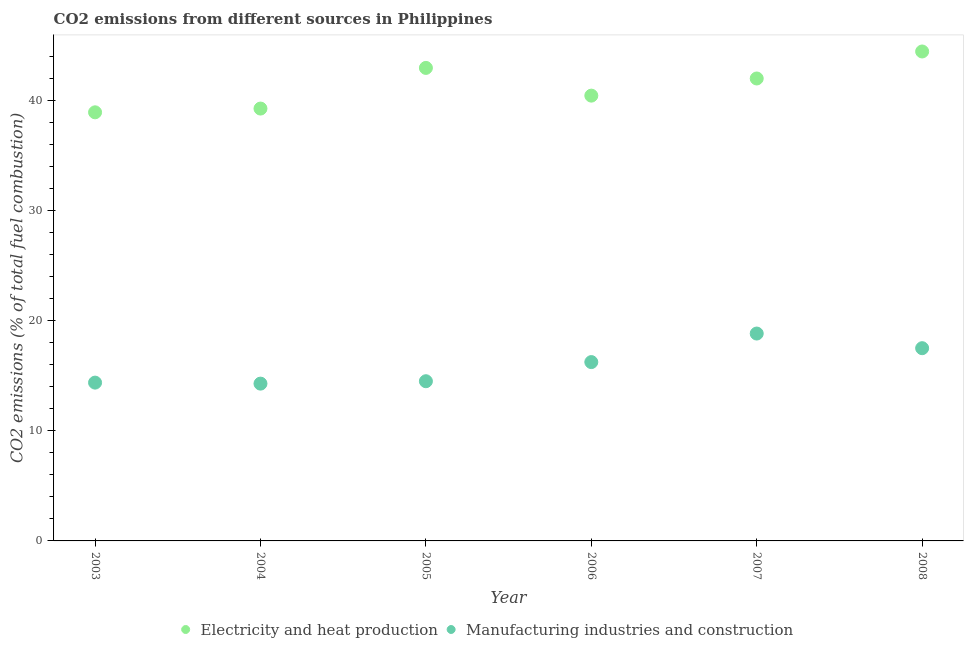How many different coloured dotlines are there?
Provide a short and direct response. 2. What is the co2 emissions due to manufacturing industries in 2003?
Provide a succinct answer. 14.38. Across all years, what is the maximum co2 emissions due to manufacturing industries?
Your response must be concise. 18.84. Across all years, what is the minimum co2 emissions due to manufacturing industries?
Provide a short and direct response. 14.29. In which year was the co2 emissions due to manufacturing industries minimum?
Your answer should be very brief. 2004. What is the total co2 emissions due to manufacturing industries in the graph?
Make the answer very short. 95.76. What is the difference between the co2 emissions due to electricity and heat production in 2006 and that in 2007?
Give a very brief answer. -1.56. What is the difference between the co2 emissions due to electricity and heat production in 2006 and the co2 emissions due to manufacturing industries in 2004?
Offer a terse response. 26.16. What is the average co2 emissions due to manufacturing industries per year?
Offer a very short reply. 15.96. In the year 2003, what is the difference between the co2 emissions due to manufacturing industries and co2 emissions due to electricity and heat production?
Make the answer very short. -24.55. In how many years, is the co2 emissions due to manufacturing industries greater than 22 %?
Ensure brevity in your answer.  0. What is the ratio of the co2 emissions due to manufacturing industries in 2005 to that in 2008?
Ensure brevity in your answer.  0.83. Is the co2 emissions due to electricity and heat production in 2003 less than that in 2006?
Offer a terse response. Yes. What is the difference between the highest and the second highest co2 emissions due to electricity and heat production?
Your response must be concise. 1.49. What is the difference between the highest and the lowest co2 emissions due to electricity and heat production?
Offer a very short reply. 5.53. Is the sum of the co2 emissions due to electricity and heat production in 2005 and 2006 greater than the maximum co2 emissions due to manufacturing industries across all years?
Offer a very short reply. Yes. How many years are there in the graph?
Give a very brief answer. 6. Does the graph contain grids?
Provide a succinct answer. No. Where does the legend appear in the graph?
Your response must be concise. Bottom center. How are the legend labels stacked?
Offer a very short reply. Horizontal. What is the title of the graph?
Offer a very short reply. CO2 emissions from different sources in Philippines. Does "Females" appear as one of the legend labels in the graph?
Give a very brief answer. No. What is the label or title of the X-axis?
Provide a succinct answer. Year. What is the label or title of the Y-axis?
Offer a very short reply. CO2 emissions (% of total fuel combustion). What is the CO2 emissions (% of total fuel combustion) of Electricity and heat production in 2003?
Your response must be concise. 38.93. What is the CO2 emissions (% of total fuel combustion) in Manufacturing industries and construction in 2003?
Offer a terse response. 14.38. What is the CO2 emissions (% of total fuel combustion) in Electricity and heat production in 2004?
Make the answer very short. 39.27. What is the CO2 emissions (% of total fuel combustion) of Manufacturing industries and construction in 2004?
Offer a very short reply. 14.29. What is the CO2 emissions (% of total fuel combustion) in Electricity and heat production in 2005?
Make the answer very short. 42.97. What is the CO2 emissions (% of total fuel combustion) of Manufacturing industries and construction in 2005?
Make the answer very short. 14.51. What is the CO2 emissions (% of total fuel combustion) in Electricity and heat production in 2006?
Your response must be concise. 40.45. What is the CO2 emissions (% of total fuel combustion) in Manufacturing industries and construction in 2006?
Your answer should be very brief. 16.24. What is the CO2 emissions (% of total fuel combustion) of Electricity and heat production in 2007?
Your answer should be compact. 42.01. What is the CO2 emissions (% of total fuel combustion) of Manufacturing industries and construction in 2007?
Ensure brevity in your answer.  18.84. What is the CO2 emissions (% of total fuel combustion) of Electricity and heat production in 2008?
Ensure brevity in your answer.  44.46. What is the CO2 emissions (% of total fuel combustion) in Manufacturing industries and construction in 2008?
Keep it short and to the point. 17.51. Across all years, what is the maximum CO2 emissions (% of total fuel combustion) in Electricity and heat production?
Give a very brief answer. 44.46. Across all years, what is the maximum CO2 emissions (% of total fuel combustion) of Manufacturing industries and construction?
Offer a very short reply. 18.84. Across all years, what is the minimum CO2 emissions (% of total fuel combustion) of Electricity and heat production?
Keep it short and to the point. 38.93. Across all years, what is the minimum CO2 emissions (% of total fuel combustion) in Manufacturing industries and construction?
Your answer should be very brief. 14.29. What is the total CO2 emissions (% of total fuel combustion) of Electricity and heat production in the graph?
Give a very brief answer. 248.09. What is the total CO2 emissions (% of total fuel combustion) of Manufacturing industries and construction in the graph?
Make the answer very short. 95.76. What is the difference between the CO2 emissions (% of total fuel combustion) in Electricity and heat production in 2003 and that in 2004?
Offer a terse response. -0.34. What is the difference between the CO2 emissions (% of total fuel combustion) in Manufacturing industries and construction in 2003 and that in 2004?
Your answer should be compact. 0.09. What is the difference between the CO2 emissions (% of total fuel combustion) in Electricity and heat production in 2003 and that in 2005?
Give a very brief answer. -4.03. What is the difference between the CO2 emissions (% of total fuel combustion) in Manufacturing industries and construction in 2003 and that in 2005?
Make the answer very short. -0.13. What is the difference between the CO2 emissions (% of total fuel combustion) of Electricity and heat production in 2003 and that in 2006?
Provide a succinct answer. -1.52. What is the difference between the CO2 emissions (% of total fuel combustion) of Manufacturing industries and construction in 2003 and that in 2006?
Provide a short and direct response. -1.86. What is the difference between the CO2 emissions (% of total fuel combustion) in Electricity and heat production in 2003 and that in 2007?
Your answer should be compact. -3.07. What is the difference between the CO2 emissions (% of total fuel combustion) in Manufacturing industries and construction in 2003 and that in 2007?
Provide a short and direct response. -4.46. What is the difference between the CO2 emissions (% of total fuel combustion) in Electricity and heat production in 2003 and that in 2008?
Give a very brief answer. -5.53. What is the difference between the CO2 emissions (% of total fuel combustion) of Manufacturing industries and construction in 2003 and that in 2008?
Keep it short and to the point. -3.13. What is the difference between the CO2 emissions (% of total fuel combustion) in Electricity and heat production in 2004 and that in 2005?
Provide a short and direct response. -3.69. What is the difference between the CO2 emissions (% of total fuel combustion) of Manufacturing industries and construction in 2004 and that in 2005?
Offer a terse response. -0.22. What is the difference between the CO2 emissions (% of total fuel combustion) of Electricity and heat production in 2004 and that in 2006?
Offer a very short reply. -1.17. What is the difference between the CO2 emissions (% of total fuel combustion) in Manufacturing industries and construction in 2004 and that in 2006?
Provide a succinct answer. -1.96. What is the difference between the CO2 emissions (% of total fuel combustion) of Electricity and heat production in 2004 and that in 2007?
Make the answer very short. -2.73. What is the difference between the CO2 emissions (% of total fuel combustion) of Manufacturing industries and construction in 2004 and that in 2007?
Offer a terse response. -4.55. What is the difference between the CO2 emissions (% of total fuel combustion) of Electricity and heat production in 2004 and that in 2008?
Offer a terse response. -5.19. What is the difference between the CO2 emissions (% of total fuel combustion) in Manufacturing industries and construction in 2004 and that in 2008?
Your answer should be compact. -3.22. What is the difference between the CO2 emissions (% of total fuel combustion) in Electricity and heat production in 2005 and that in 2006?
Keep it short and to the point. 2.52. What is the difference between the CO2 emissions (% of total fuel combustion) of Manufacturing industries and construction in 2005 and that in 2006?
Your answer should be compact. -1.74. What is the difference between the CO2 emissions (% of total fuel combustion) of Electricity and heat production in 2005 and that in 2007?
Offer a terse response. 0.96. What is the difference between the CO2 emissions (% of total fuel combustion) of Manufacturing industries and construction in 2005 and that in 2007?
Keep it short and to the point. -4.33. What is the difference between the CO2 emissions (% of total fuel combustion) of Electricity and heat production in 2005 and that in 2008?
Offer a terse response. -1.49. What is the difference between the CO2 emissions (% of total fuel combustion) in Manufacturing industries and construction in 2005 and that in 2008?
Provide a succinct answer. -3. What is the difference between the CO2 emissions (% of total fuel combustion) in Electricity and heat production in 2006 and that in 2007?
Your answer should be compact. -1.56. What is the difference between the CO2 emissions (% of total fuel combustion) in Manufacturing industries and construction in 2006 and that in 2007?
Your answer should be compact. -2.59. What is the difference between the CO2 emissions (% of total fuel combustion) in Electricity and heat production in 2006 and that in 2008?
Give a very brief answer. -4.01. What is the difference between the CO2 emissions (% of total fuel combustion) of Manufacturing industries and construction in 2006 and that in 2008?
Your response must be concise. -1.26. What is the difference between the CO2 emissions (% of total fuel combustion) in Electricity and heat production in 2007 and that in 2008?
Ensure brevity in your answer.  -2.45. What is the difference between the CO2 emissions (% of total fuel combustion) of Manufacturing industries and construction in 2007 and that in 2008?
Ensure brevity in your answer.  1.33. What is the difference between the CO2 emissions (% of total fuel combustion) in Electricity and heat production in 2003 and the CO2 emissions (% of total fuel combustion) in Manufacturing industries and construction in 2004?
Your answer should be compact. 24.65. What is the difference between the CO2 emissions (% of total fuel combustion) in Electricity and heat production in 2003 and the CO2 emissions (% of total fuel combustion) in Manufacturing industries and construction in 2005?
Keep it short and to the point. 24.43. What is the difference between the CO2 emissions (% of total fuel combustion) of Electricity and heat production in 2003 and the CO2 emissions (% of total fuel combustion) of Manufacturing industries and construction in 2006?
Ensure brevity in your answer.  22.69. What is the difference between the CO2 emissions (% of total fuel combustion) of Electricity and heat production in 2003 and the CO2 emissions (% of total fuel combustion) of Manufacturing industries and construction in 2007?
Make the answer very short. 20.1. What is the difference between the CO2 emissions (% of total fuel combustion) of Electricity and heat production in 2003 and the CO2 emissions (% of total fuel combustion) of Manufacturing industries and construction in 2008?
Provide a short and direct response. 21.43. What is the difference between the CO2 emissions (% of total fuel combustion) in Electricity and heat production in 2004 and the CO2 emissions (% of total fuel combustion) in Manufacturing industries and construction in 2005?
Offer a terse response. 24.77. What is the difference between the CO2 emissions (% of total fuel combustion) of Electricity and heat production in 2004 and the CO2 emissions (% of total fuel combustion) of Manufacturing industries and construction in 2006?
Make the answer very short. 23.03. What is the difference between the CO2 emissions (% of total fuel combustion) of Electricity and heat production in 2004 and the CO2 emissions (% of total fuel combustion) of Manufacturing industries and construction in 2007?
Provide a succinct answer. 20.44. What is the difference between the CO2 emissions (% of total fuel combustion) in Electricity and heat production in 2004 and the CO2 emissions (% of total fuel combustion) in Manufacturing industries and construction in 2008?
Ensure brevity in your answer.  21.77. What is the difference between the CO2 emissions (% of total fuel combustion) in Electricity and heat production in 2005 and the CO2 emissions (% of total fuel combustion) in Manufacturing industries and construction in 2006?
Provide a succinct answer. 26.72. What is the difference between the CO2 emissions (% of total fuel combustion) in Electricity and heat production in 2005 and the CO2 emissions (% of total fuel combustion) in Manufacturing industries and construction in 2007?
Make the answer very short. 24.13. What is the difference between the CO2 emissions (% of total fuel combustion) of Electricity and heat production in 2005 and the CO2 emissions (% of total fuel combustion) of Manufacturing industries and construction in 2008?
Your answer should be very brief. 25.46. What is the difference between the CO2 emissions (% of total fuel combustion) in Electricity and heat production in 2006 and the CO2 emissions (% of total fuel combustion) in Manufacturing industries and construction in 2007?
Offer a very short reply. 21.61. What is the difference between the CO2 emissions (% of total fuel combustion) of Electricity and heat production in 2006 and the CO2 emissions (% of total fuel combustion) of Manufacturing industries and construction in 2008?
Make the answer very short. 22.94. What is the difference between the CO2 emissions (% of total fuel combustion) in Electricity and heat production in 2007 and the CO2 emissions (% of total fuel combustion) in Manufacturing industries and construction in 2008?
Make the answer very short. 24.5. What is the average CO2 emissions (% of total fuel combustion) of Electricity and heat production per year?
Give a very brief answer. 41.35. What is the average CO2 emissions (% of total fuel combustion) in Manufacturing industries and construction per year?
Your answer should be compact. 15.96. In the year 2003, what is the difference between the CO2 emissions (% of total fuel combustion) in Electricity and heat production and CO2 emissions (% of total fuel combustion) in Manufacturing industries and construction?
Provide a succinct answer. 24.55. In the year 2004, what is the difference between the CO2 emissions (% of total fuel combustion) of Electricity and heat production and CO2 emissions (% of total fuel combustion) of Manufacturing industries and construction?
Ensure brevity in your answer.  24.99. In the year 2005, what is the difference between the CO2 emissions (% of total fuel combustion) in Electricity and heat production and CO2 emissions (% of total fuel combustion) in Manufacturing industries and construction?
Your response must be concise. 28.46. In the year 2006, what is the difference between the CO2 emissions (% of total fuel combustion) in Electricity and heat production and CO2 emissions (% of total fuel combustion) in Manufacturing industries and construction?
Provide a short and direct response. 24.2. In the year 2007, what is the difference between the CO2 emissions (% of total fuel combustion) in Electricity and heat production and CO2 emissions (% of total fuel combustion) in Manufacturing industries and construction?
Offer a terse response. 23.17. In the year 2008, what is the difference between the CO2 emissions (% of total fuel combustion) of Electricity and heat production and CO2 emissions (% of total fuel combustion) of Manufacturing industries and construction?
Offer a very short reply. 26.95. What is the ratio of the CO2 emissions (% of total fuel combustion) of Manufacturing industries and construction in 2003 to that in 2004?
Your answer should be compact. 1.01. What is the ratio of the CO2 emissions (% of total fuel combustion) of Electricity and heat production in 2003 to that in 2005?
Provide a succinct answer. 0.91. What is the ratio of the CO2 emissions (% of total fuel combustion) of Electricity and heat production in 2003 to that in 2006?
Keep it short and to the point. 0.96. What is the ratio of the CO2 emissions (% of total fuel combustion) of Manufacturing industries and construction in 2003 to that in 2006?
Your response must be concise. 0.89. What is the ratio of the CO2 emissions (% of total fuel combustion) in Electricity and heat production in 2003 to that in 2007?
Offer a terse response. 0.93. What is the ratio of the CO2 emissions (% of total fuel combustion) of Manufacturing industries and construction in 2003 to that in 2007?
Make the answer very short. 0.76. What is the ratio of the CO2 emissions (% of total fuel combustion) in Electricity and heat production in 2003 to that in 2008?
Offer a very short reply. 0.88. What is the ratio of the CO2 emissions (% of total fuel combustion) of Manufacturing industries and construction in 2003 to that in 2008?
Give a very brief answer. 0.82. What is the ratio of the CO2 emissions (% of total fuel combustion) in Electricity and heat production in 2004 to that in 2005?
Provide a succinct answer. 0.91. What is the ratio of the CO2 emissions (% of total fuel combustion) in Manufacturing industries and construction in 2004 to that in 2005?
Offer a very short reply. 0.98. What is the ratio of the CO2 emissions (% of total fuel combustion) of Electricity and heat production in 2004 to that in 2006?
Your response must be concise. 0.97. What is the ratio of the CO2 emissions (% of total fuel combustion) of Manufacturing industries and construction in 2004 to that in 2006?
Your response must be concise. 0.88. What is the ratio of the CO2 emissions (% of total fuel combustion) of Electricity and heat production in 2004 to that in 2007?
Make the answer very short. 0.94. What is the ratio of the CO2 emissions (% of total fuel combustion) of Manufacturing industries and construction in 2004 to that in 2007?
Provide a short and direct response. 0.76. What is the ratio of the CO2 emissions (% of total fuel combustion) of Electricity and heat production in 2004 to that in 2008?
Provide a short and direct response. 0.88. What is the ratio of the CO2 emissions (% of total fuel combustion) in Manufacturing industries and construction in 2004 to that in 2008?
Provide a short and direct response. 0.82. What is the ratio of the CO2 emissions (% of total fuel combustion) of Electricity and heat production in 2005 to that in 2006?
Ensure brevity in your answer.  1.06. What is the ratio of the CO2 emissions (% of total fuel combustion) of Manufacturing industries and construction in 2005 to that in 2006?
Give a very brief answer. 0.89. What is the ratio of the CO2 emissions (% of total fuel combustion) in Electricity and heat production in 2005 to that in 2007?
Your answer should be very brief. 1.02. What is the ratio of the CO2 emissions (% of total fuel combustion) of Manufacturing industries and construction in 2005 to that in 2007?
Your answer should be very brief. 0.77. What is the ratio of the CO2 emissions (% of total fuel combustion) of Electricity and heat production in 2005 to that in 2008?
Offer a terse response. 0.97. What is the ratio of the CO2 emissions (% of total fuel combustion) of Manufacturing industries and construction in 2005 to that in 2008?
Your answer should be very brief. 0.83. What is the ratio of the CO2 emissions (% of total fuel combustion) in Electricity and heat production in 2006 to that in 2007?
Give a very brief answer. 0.96. What is the ratio of the CO2 emissions (% of total fuel combustion) of Manufacturing industries and construction in 2006 to that in 2007?
Keep it short and to the point. 0.86. What is the ratio of the CO2 emissions (% of total fuel combustion) in Electricity and heat production in 2006 to that in 2008?
Offer a terse response. 0.91. What is the ratio of the CO2 emissions (% of total fuel combustion) in Manufacturing industries and construction in 2006 to that in 2008?
Your answer should be very brief. 0.93. What is the ratio of the CO2 emissions (% of total fuel combustion) in Electricity and heat production in 2007 to that in 2008?
Ensure brevity in your answer.  0.94. What is the ratio of the CO2 emissions (% of total fuel combustion) of Manufacturing industries and construction in 2007 to that in 2008?
Offer a terse response. 1.08. What is the difference between the highest and the second highest CO2 emissions (% of total fuel combustion) in Electricity and heat production?
Provide a short and direct response. 1.49. What is the difference between the highest and the second highest CO2 emissions (% of total fuel combustion) in Manufacturing industries and construction?
Give a very brief answer. 1.33. What is the difference between the highest and the lowest CO2 emissions (% of total fuel combustion) of Electricity and heat production?
Offer a very short reply. 5.53. What is the difference between the highest and the lowest CO2 emissions (% of total fuel combustion) in Manufacturing industries and construction?
Ensure brevity in your answer.  4.55. 